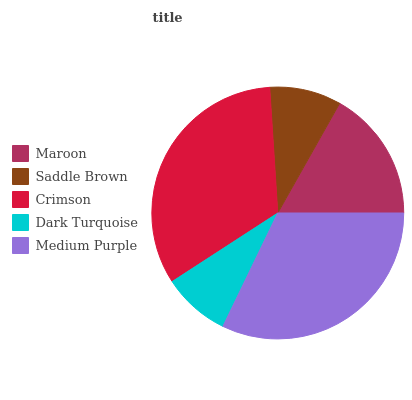Is Dark Turquoise the minimum?
Answer yes or no. Yes. Is Crimson the maximum?
Answer yes or no. Yes. Is Saddle Brown the minimum?
Answer yes or no. No. Is Saddle Brown the maximum?
Answer yes or no. No. Is Maroon greater than Saddle Brown?
Answer yes or no. Yes. Is Saddle Brown less than Maroon?
Answer yes or no. Yes. Is Saddle Brown greater than Maroon?
Answer yes or no. No. Is Maroon less than Saddle Brown?
Answer yes or no. No. Is Maroon the high median?
Answer yes or no. Yes. Is Maroon the low median?
Answer yes or no. Yes. Is Saddle Brown the high median?
Answer yes or no. No. Is Crimson the low median?
Answer yes or no. No. 